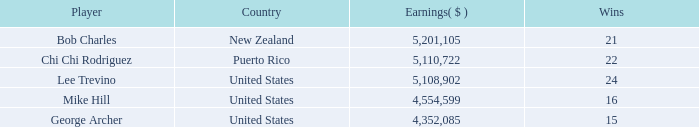On average, how many wins have a rank lower than 1? None. 